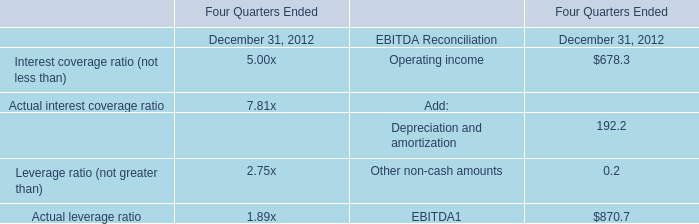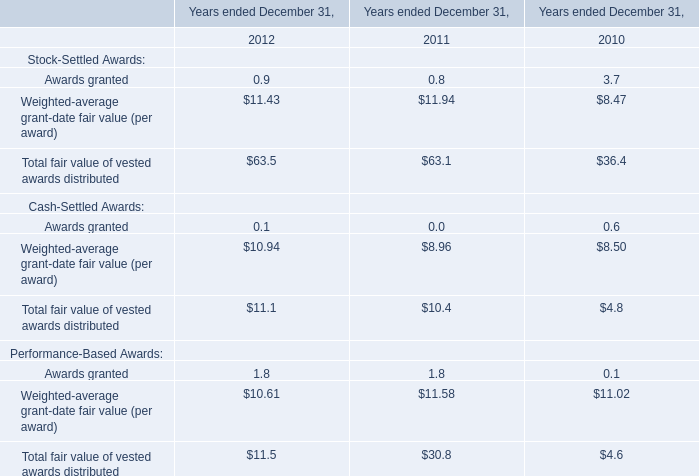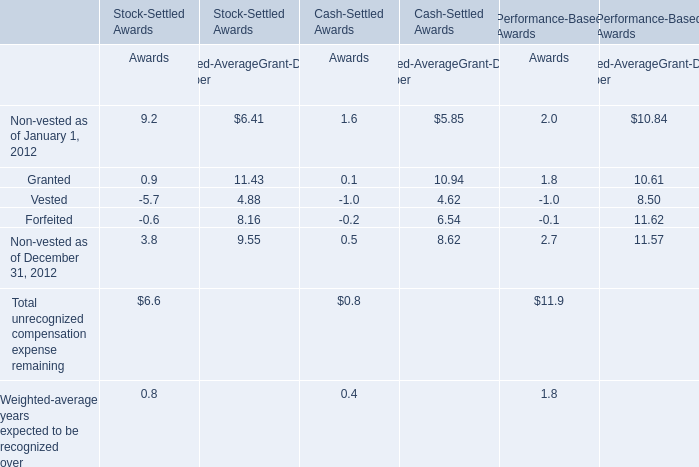What is the Awards value of Total unrecognized compensation expense remaining that is less than the 50% of the Awards value of Total unrecognized compensation expense remaining for Stock-Settled Awards? 
Answer: 0.8. 